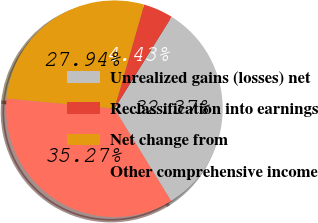<chart> <loc_0><loc_0><loc_500><loc_500><pie_chart><fcel>Unrealized gains (losses) net<fcel>Reclassification into earnings<fcel>Net change from<fcel>Other comprehensive income<nl><fcel>32.37%<fcel>4.43%<fcel>27.94%<fcel>35.27%<nl></chart> 